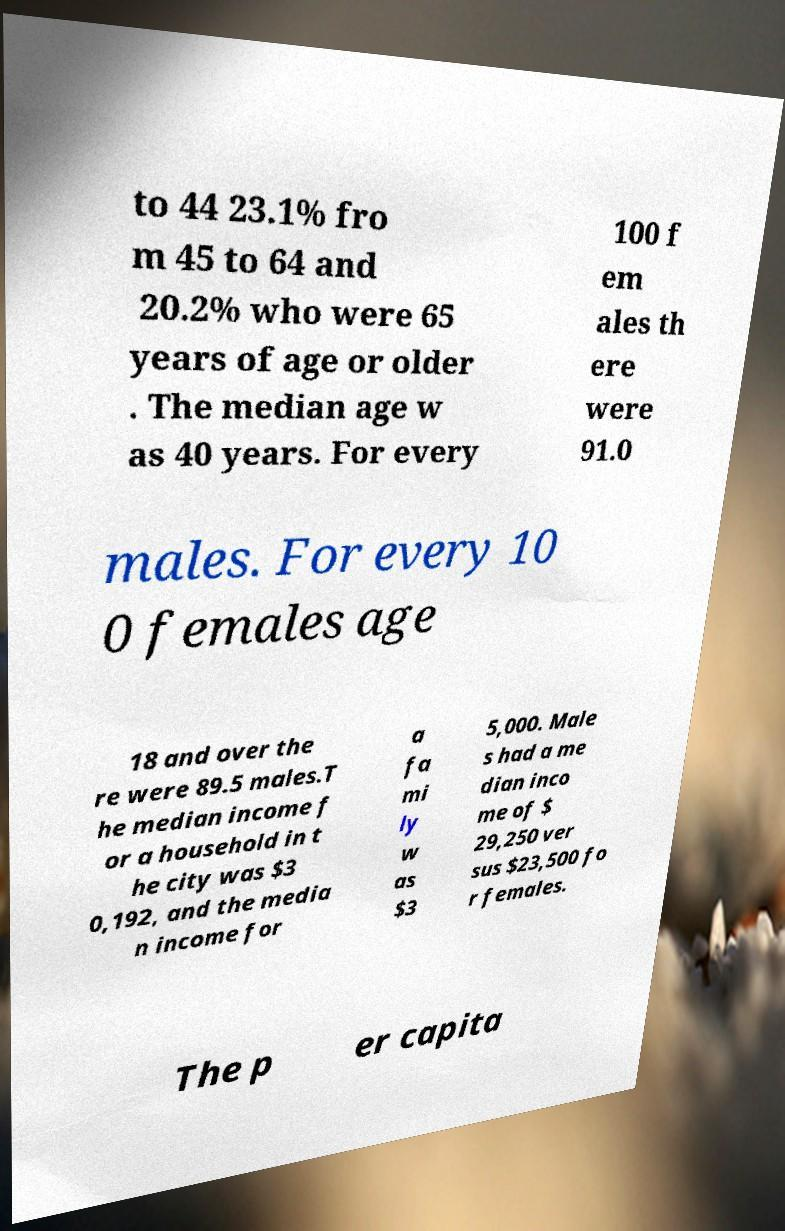Could you extract and type out the text from this image? to 44 23.1% fro m 45 to 64 and 20.2% who were 65 years of age or older . The median age w as 40 years. For every 100 f em ales th ere were 91.0 males. For every 10 0 females age 18 and over the re were 89.5 males.T he median income f or a household in t he city was $3 0,192, and the media n income for a fa mi ly w as $3 5,000. Male s had a me dian inco me of $ 29,250 ver sus $23,500 fo r females. The p er capita 